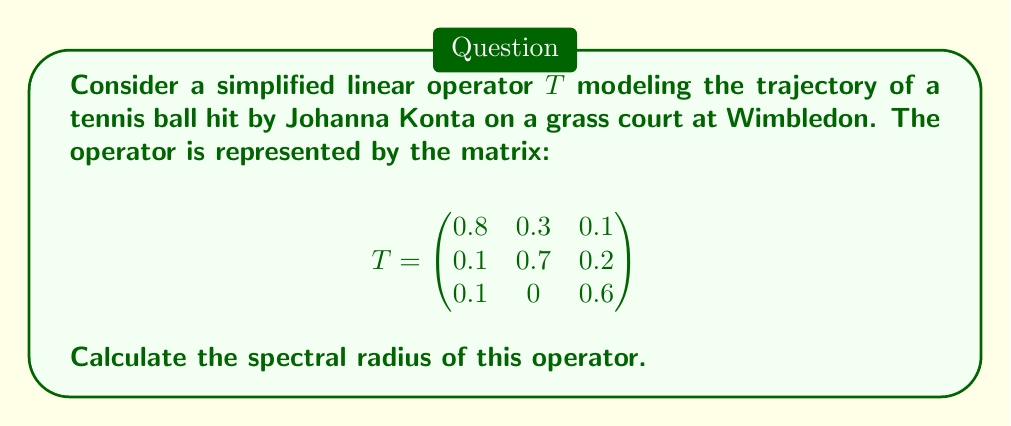Help me with this question. To find the spectral radius of the linear operator $T$, we need to follow these steps:

1) First, we need to find the eigenvalues of the matrix $T$. The characteristic equation is:

   $$\det(T - \lambda I) = 0$$

   $$(0.8 - \lambda)(0.7 - \lambda)(0.6 - \lambda) - 0.1(0.7 - \lambda)(0.1) - 0.3(0.1)(0.6 - \lambda) = 0$$

2) Expanding this equation:

   $$\lambda^3 - 2.1\lambda^2 + 1.39\lambda - 0.286 = 0$$

3) This cubic equation can be solved using numerical methods. The eigenvalues are approximately:

   $$\lambda_1 \approx 0.9397$$
   $$\lambda_2 \approx 0.6301$$
   $$\lambda_3 \approx 0.5302$$

4) The spectral radius $\rho(T)$ is defined as the maximum of the absolute values of the eigenvalues:

   $$\rho(T) = \max\{|\lambda_1|, |\lambda_2|, |\lambda_3|\}$$

5) In this case, the largest absolute value is $|\lambda_1| \approx 0.9397$.

Therefore, the spectral radius of the operator $T$ is approximately 0.9397.
Answer: $\rho(T) \approx 0.9397$ 